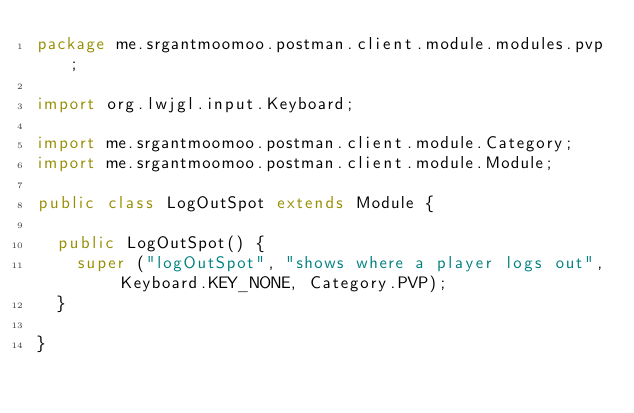<code> <loc_0><loc_0><loc_500><loc_500><_Java_>package me.srgantmoomoo.postman.client.module.modules.pvp;

import org.lwjgl.input.Keyboard;

import me.srgantmoomoo.postman.client.module.Category;
import me.srgantmoomoo.postman.client.module.Module;

public class LogOutSpot extends Module {
	
	public LogOutSpot() {
		super ("logOutSpot", "shows where a player logs out", Keyboard.KEY_NONE, Category.PVP);
	}

}
</code> 